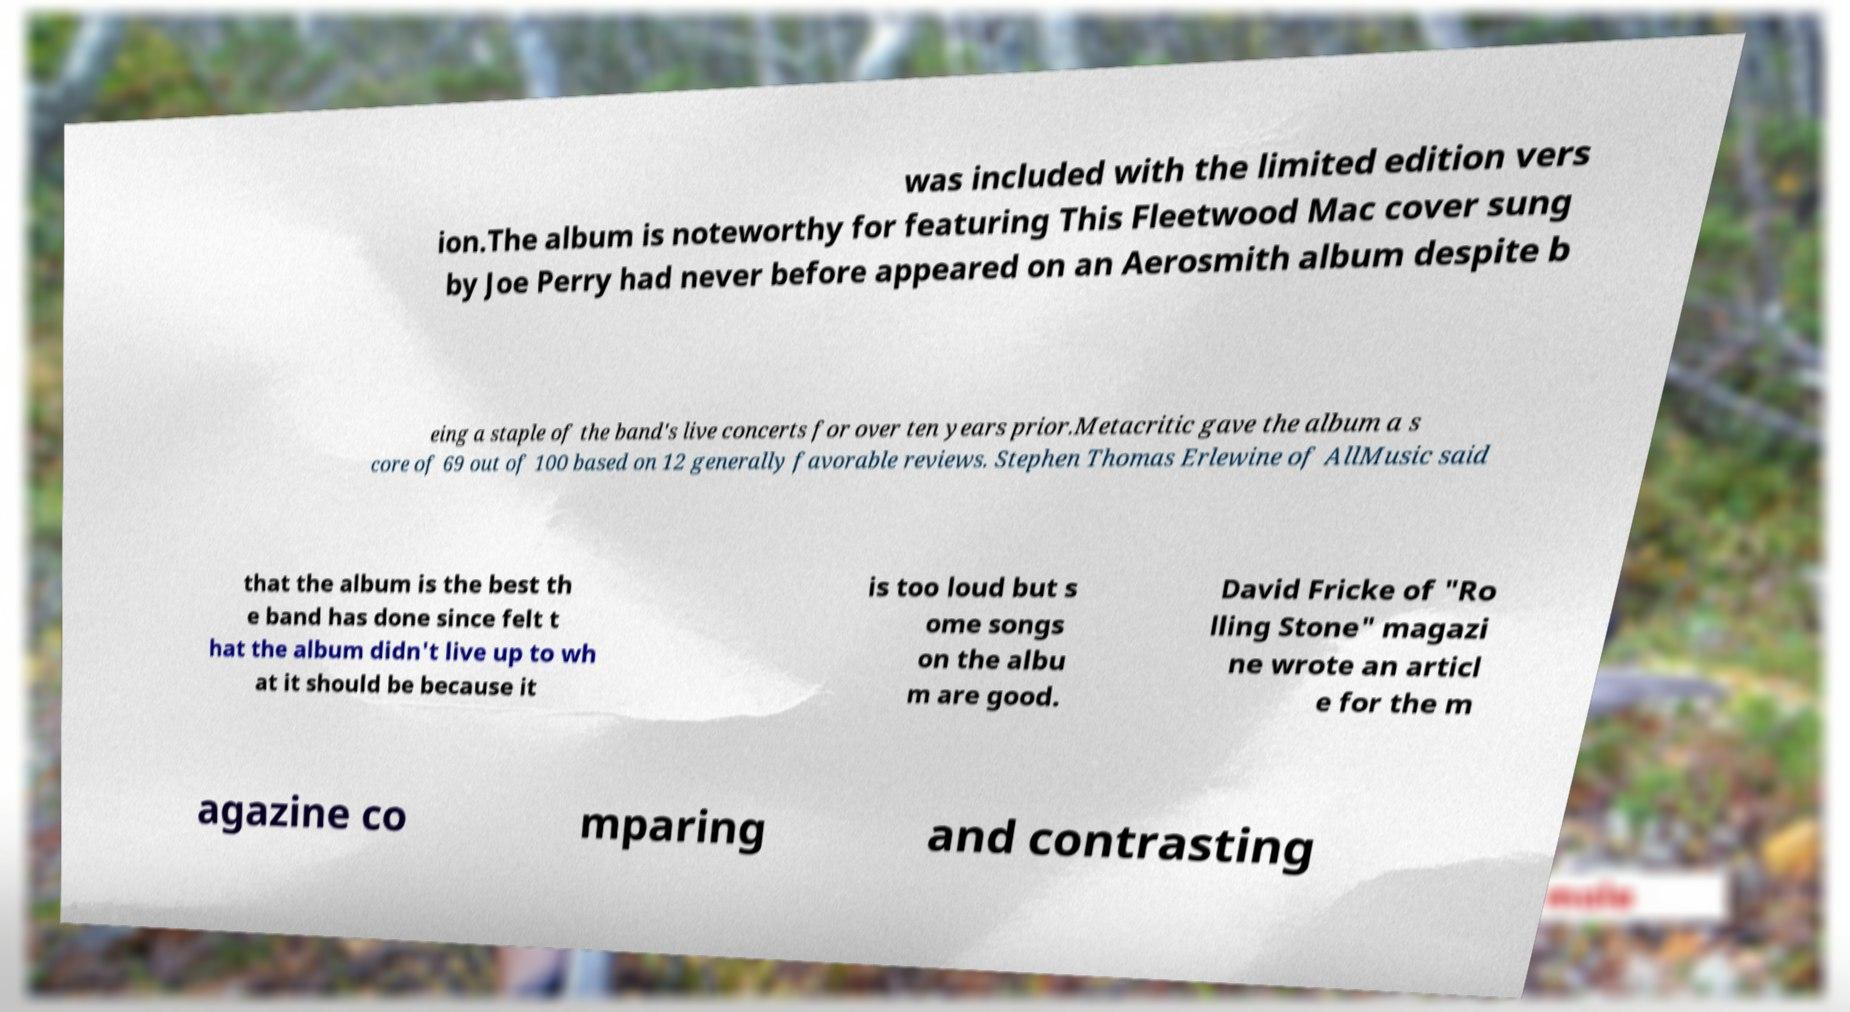Could you assist in decoding the text presented in this image and type it out clearly? was included with the limited edition vers ion.The album is noteworthy for featuring This Fleetwood Mac cover sung by Joe Perry had never before appeared on an Aerosmith album despite b eing a staple of the band's live concerts for over ten years prior.Metacritic gave the album a s core of 69 out of 100 based on 12 generally favorable reviews. Stephen Thomas Erlewine of AllMusic said that the album is the best th e band has done since felt t hat the album didn't live up to wh at it should be because it is too loud but s ome songs on the albu m are good. David Fricke of "Ro lling Stone" magazi ne wrote an articl e for the m agazine co mparing and contrasting 